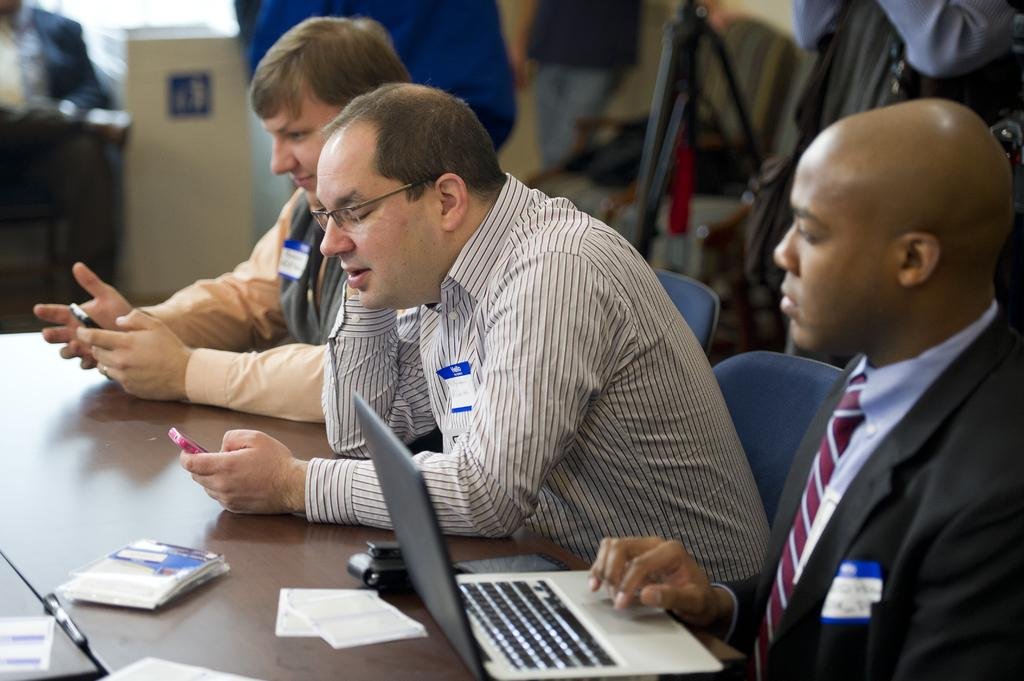What are the people in the image doing? There are persons sitting at the table in the image. What electronic devices can be seen on the table? There is a mobile phone and a laptop on the table. What is present in the background of the image? There is a camera stand, persons, a cupboard, and a wall in the background. What type of yard can be seen in the image? There is no yard present in the image; it features a room with a table, electronic devices, and a background with various elements. 